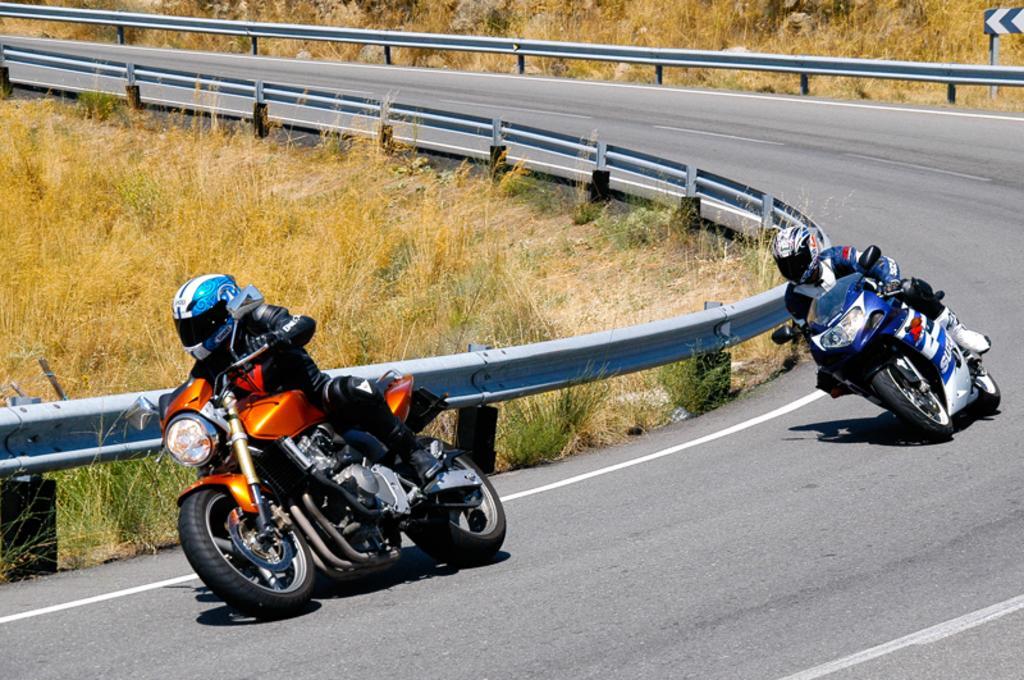How would you summarize this image in a sentence or two? In this image we can see there are persons riding a motorcycle on the road. At the side there is a railing, board and grass. 